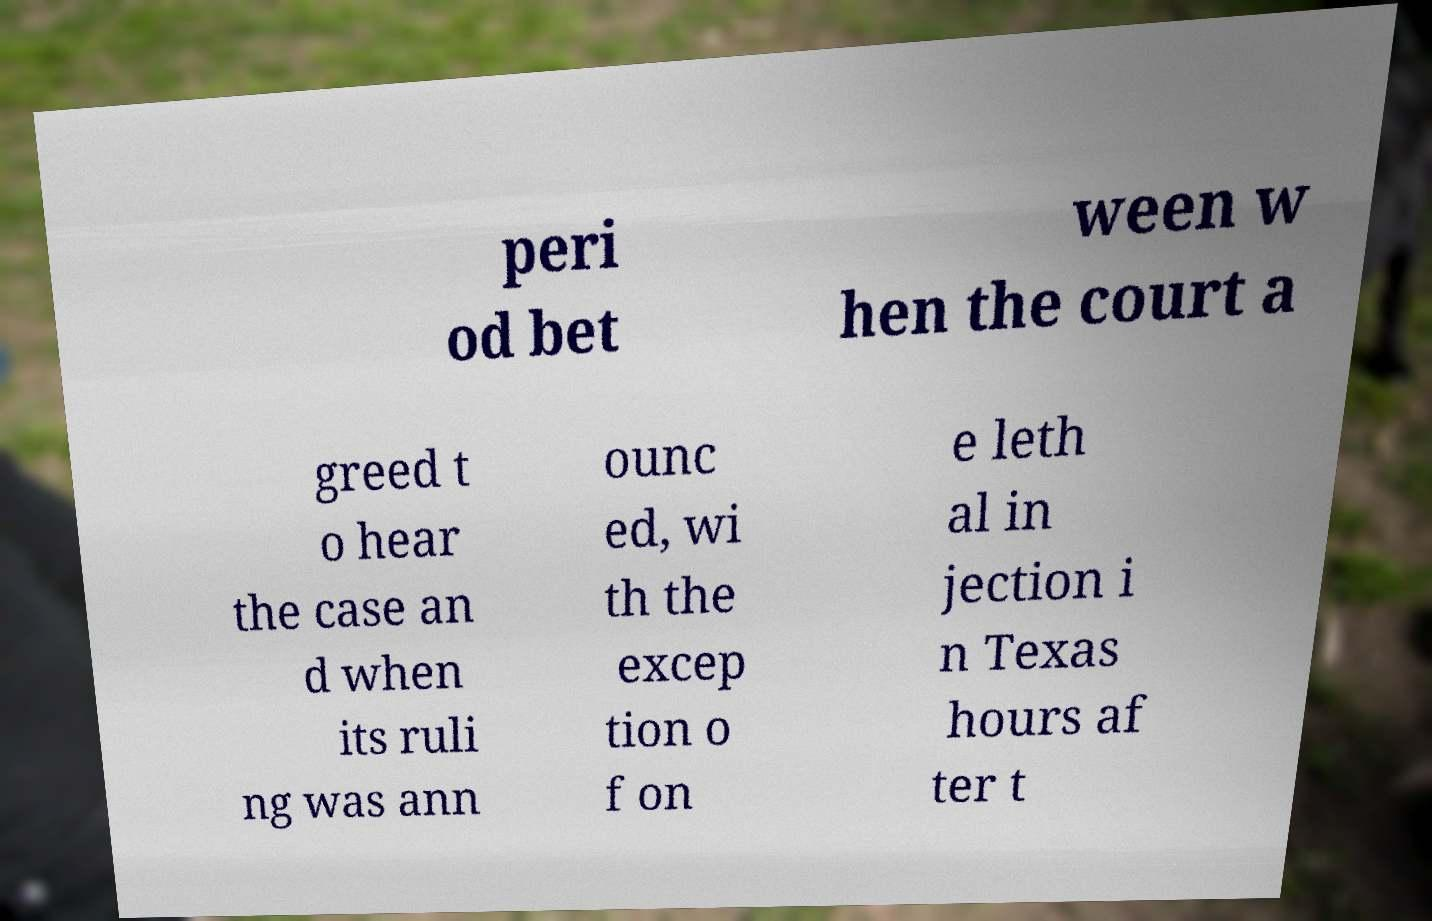Could you assist in decoding the text presented in this image and type it out clearly? peri od bet ween w hen the court a greed t o hear the case an d when its ruli ng was ann ounc ed, wi th the excep tion o f on e leth al in jection i n Texas hours af ter t 